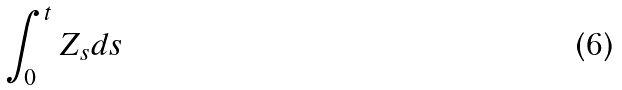Convert formula to latex. <formula><loc_0><loc_0><loc_500><loc_500>\int _ { 0 } ^ { t } Z _ { s } d s</formula> 